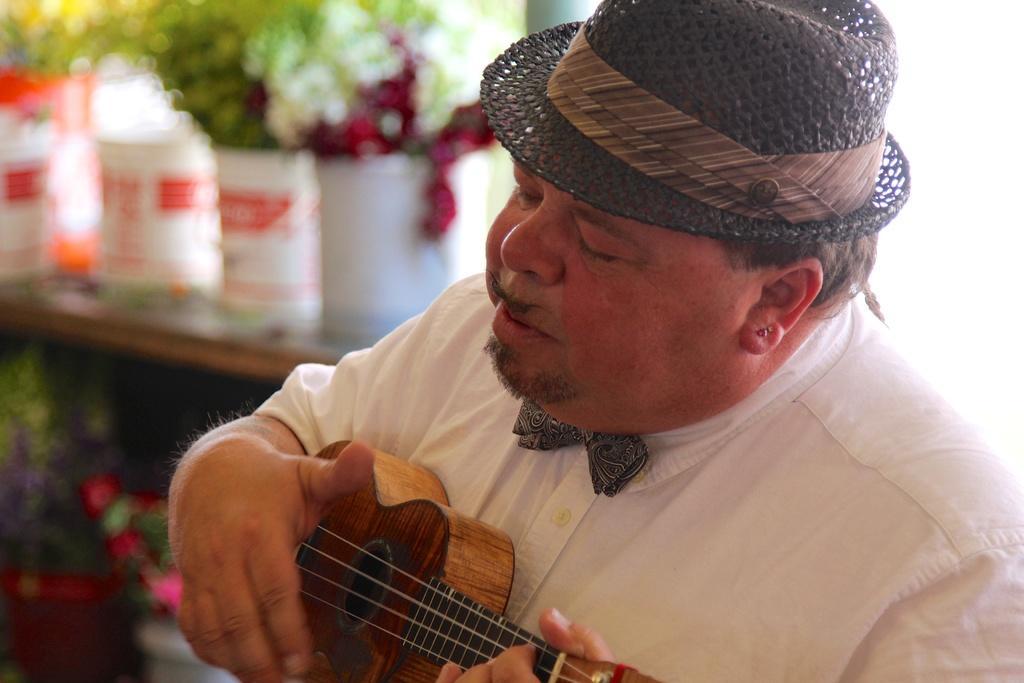Please provide a concise description of this image. This image consists of a person who is playing guitar. He has a hat. There are plants on the left side. He is wearing white dress. 